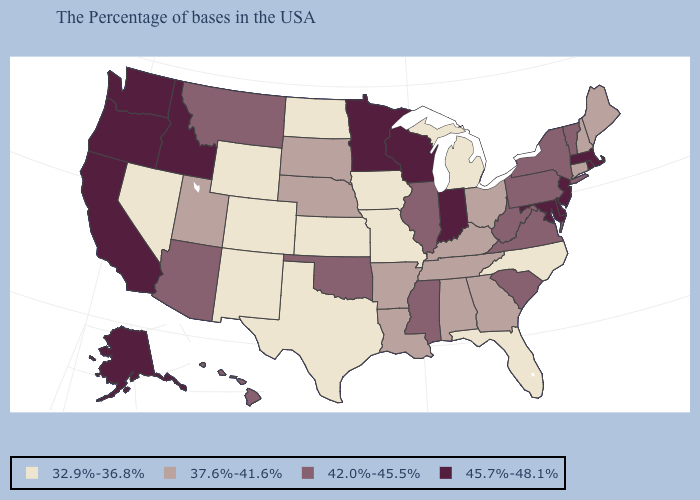Name the states that have a value in the range 42.0%-45.5%?
Keep it brief. Vermont, New York, Pennsylvania, Virginia, South Carolina, West Virginia, Illinois, Mississippi, Oklahoma, Montana, Arizona, Hawaii. Which states have the lowest value in the USA?
Give a very brief answer. North Carolina, Florida, Michigan, Missouri, Iowa, Kansas, Texas, North Dakota, Wyoming, Colorado, New Mexico, Nevada. Does Nevada have the lowest value in the USA?
Answer briefly. Yes. What is the value of South Carolina?
Quick response, please. 42.0%-45.5%. Does South Dakota have a lower value than New Jersey?
Be succinct. Yes. Which states hav the highest value in the MidWest?
Short answer required. Indiana, Wisconsin, Minnesota. Name the states that have a value in the range 42.0%-45.5%?
Quick response, please. Vermont, New York, Pennsylvania, Virginia, South Carolina, West Virginia, Illinois, Mississippi, Oklahoma, Montana, Arizona, Hawaii. Does Virginia have the lowest value in the South?
Give a very brief answer. No. Is the legend a continuous bar?
Answer briefly. No. Does Hawaii have the lowest value in the West?
Give a very brief answer. No. Name the states that have a value in the range 42.0%-45.5%?
Quick response, please. Vermont, New York, Pennsylvania, Virginia, South Carolina, West Virginia, Illinois, Mississippi, Oklahoma, Montana, Arizona, Hawaii. Name the states that have a value in the range 42.0%-45.5%?
Write a very short answer. Vermont, New York, Pennsylvania, Virginia, South Carolina, West Virginia, Illinois, Mississippi, Oklahoma, Montana, Arizona, Hawaii. What is the value of Maine?
Answer briefly. 37.6%-41.6%. Which states have the highest value in the USA?
Write a very short answer. Massachusetts, Rhode Island, New Jersey, Delaware, Maryland, Indiana, Wisconsin, Minnesota, Idaho, California, Washington, Oregon, Alaska. Is the legend a continuous bar?
Quick response, please. No. 